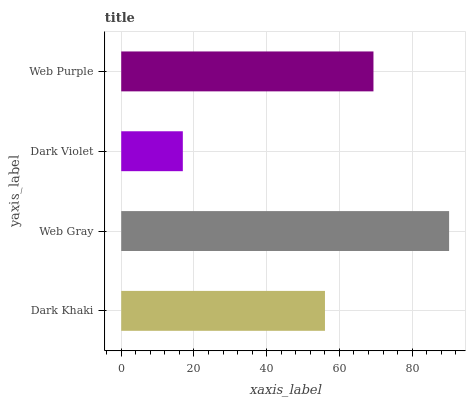Is Dark Violet the minimum?
Answer yes or no. Yes. Is Web Gray the maximum?
Answer yes or no. Yes. Is Web Gray the minimum?
Answer yes or no. No. Is Dark Violet the maximum?
Answer yes or no. No. Is Web Gray greater than Dark Violet?
Answer yes or no. Yes. Is Dark Violet less than Web Gray?
Answer yes or no. Yes. Is Dark Violet greater than Web Gray?
Answer yes or no. No. Is Web Gray less than Dark Violet?
Answer yes or no. No. Is Web Purple the high median?
Answer yes or no. Yes. Is Dark Khaki the low median?
Answer yes or no. Yes. Is Web Gray the high median?
Answer yes or no. No. Is Web Purple the low median?
Answer yes or no. No. 